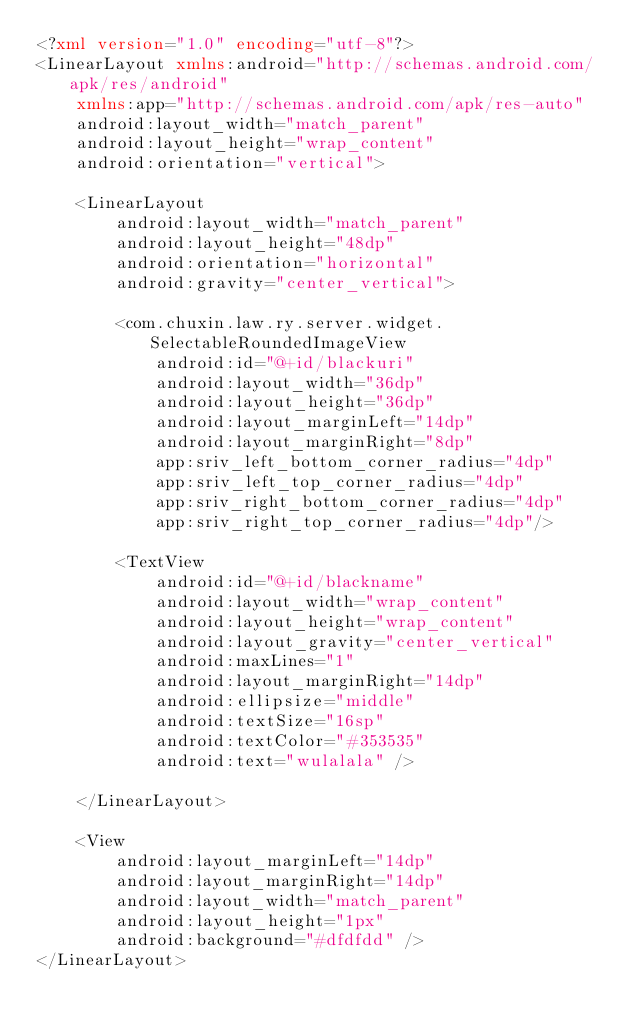<code> <loc_0><loc_0><loc_500><loc_500><_XML_><?xml version="1.0" encoding="utf-8"?>
<LinearLayout xmlns:android="http://schemas.android.com/apk/res/android"
    xmlns:app="http://schemas.android.com/apk/res-auto"
    android:layout_width="match_parent"
    android:layout_height="wrap_content"
    android:orientation="vertical">

    <LinearLayout
        android:layout_width="match_parent"
        android:layout_height="48dp"
        android:orientation="horizontal"
        android:gravity="center_vertical">

        <com.chuxin.law.ry.server.widget.SelectableRoundedImageView
            android:id="@+id/blackuri"
            android:layout_width="36dp"
            android:layout_height="36dp"
            android:layout_marginLeft="14dp"
            android:layout_marginRight="8dp"
            app:sriv_left_bottom_corner_radius="4dp"
            app:sriv_left_top_corner_radius="4dp"
            app:sriv_right_bottom_corner_radius="4dp"
            app:sriv_right_top_corner_radius="4dp"/>

        <TextView
            android:id="@+id/blackname"
            android:layout_width="wrap_content"
            android:layout_height="wrap_content"
            android:layout_gravity="center_vertical"
            android:maxLines="1"
            android:layout_marginRight="14dp"
            android:ellipsize="middle"
            android:textSize="16sp"
            android:textColor="#353535"
            android:text="wulalala" />

    </LinearLayout>

    <View
        android:layout_marginLeft="14dp"
        android:layout_marginRight="14dp"
        android:layout_width="match_parent"
        android:layout_height="1px"
        android:background="#dfdfdd" />
</LinearLayout></code> 